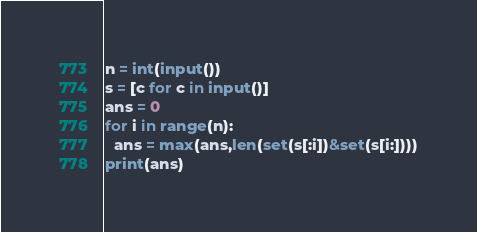Convert code to text. <code><loc_0><loc_0><loc_500><loc_500><_Python_>n = int(input())
s = [c for c in input()]
ans = 0
for i in range(n):
  ans = max(ans,len(set(s[:i])&set(s[i:])))
print(ans)</code> 